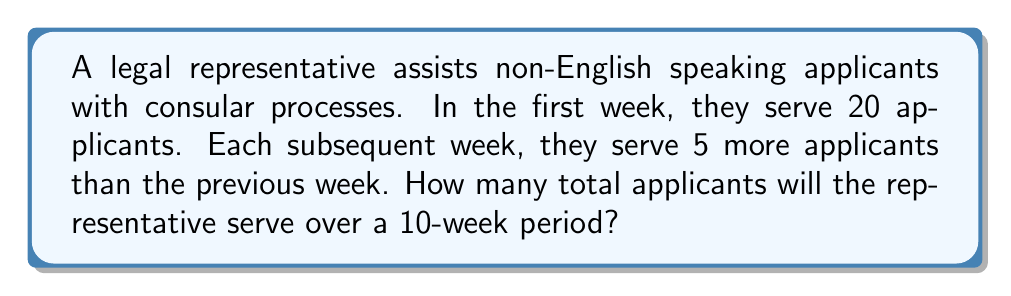Help me with this question. Let's approach this step-by-step using an arithmetic sequence:

1) First, identify the components of the arithmetic sequence:
   $a_1 = 20$ (first term)
   $d = 5$ (common difference)
   $n = 10$ (number of terms)

2) The sequence of applicants served each week will be:
   Week 1: 20
   Week 2: 25
   Week 3: 30
   ...and so on

3) To find the total number of applicants, we need to find the sum of this arithmetic sequence. We can use the formula:

   $$S_n = \frac{n}{2}(a_1 + a_n)$$

   Where $a_n$ is the last term of the sequence.

4) To find $a_n$, we can use the arithmetic sequence formula:
   $$a_n = a_1 + (n-1)d$$
   $$a_{10} = 20 + (10-1)5 = 20 + 45 = 65$$

5) Now we can substitute into our sum formula:
   $$S_{10} = \frac{10}{2}(20 + 65) = 5(85) = 425$$

Therefore, the legal representative will serve a total of 425 applicants over the 10-week period.
Answer: 425 applicants 